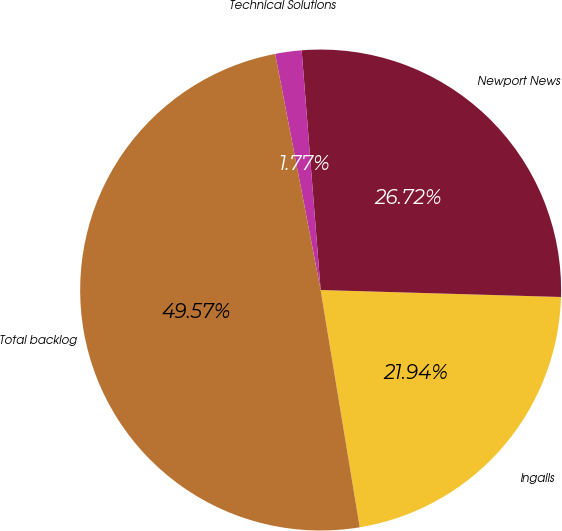Convert chart. <chart><loc_0><loc_0><loc_500><loc_500><pie_chart><fcel>Ingalls<fcel>Newport News<fcel>Technical Solutions<fcel>Total backlog<nl><fcel>21.94%<fcel>26.72%<fcel>1.77%<fcel>49.57%<nl></chart> 